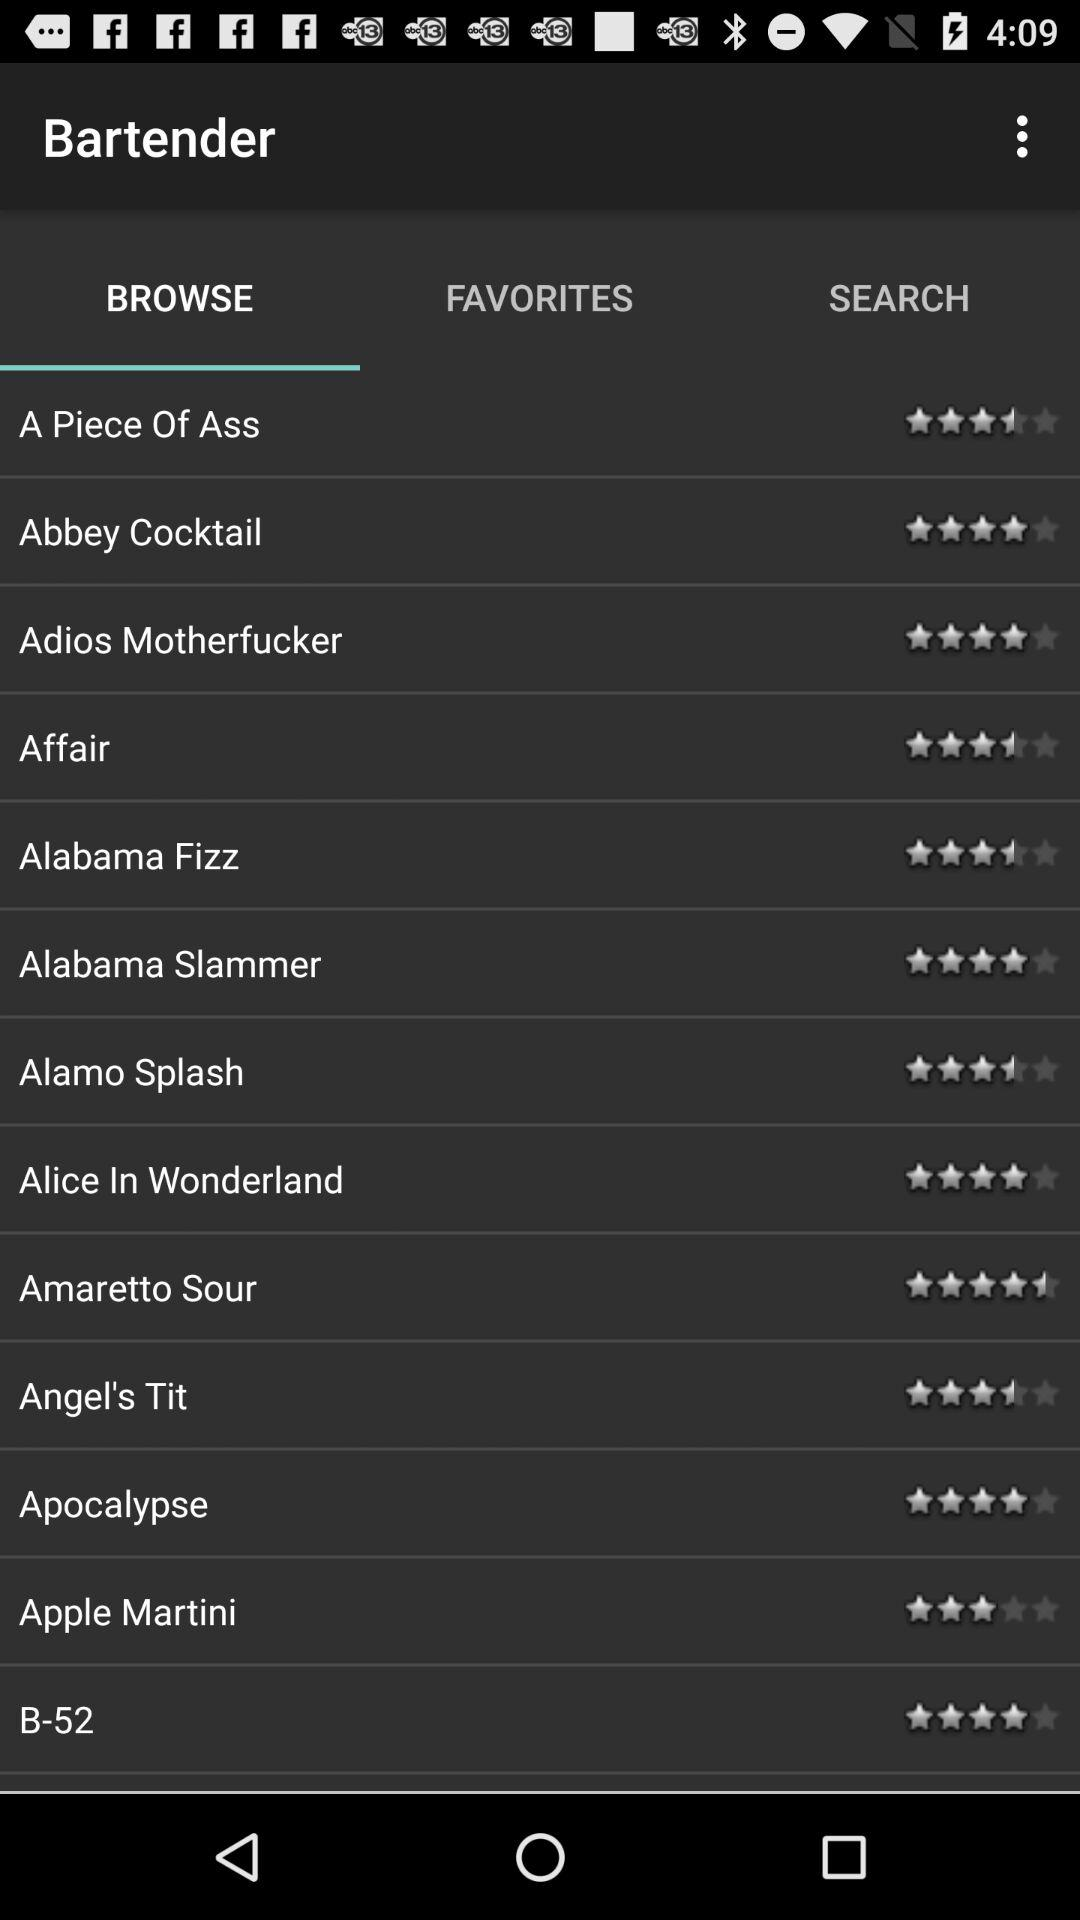What is the name of the application? The name of the application is "Bartender". 